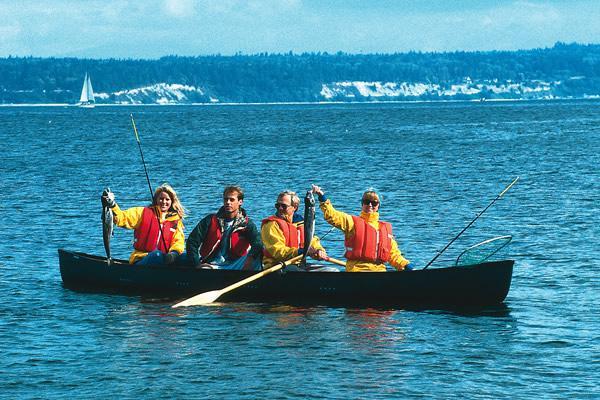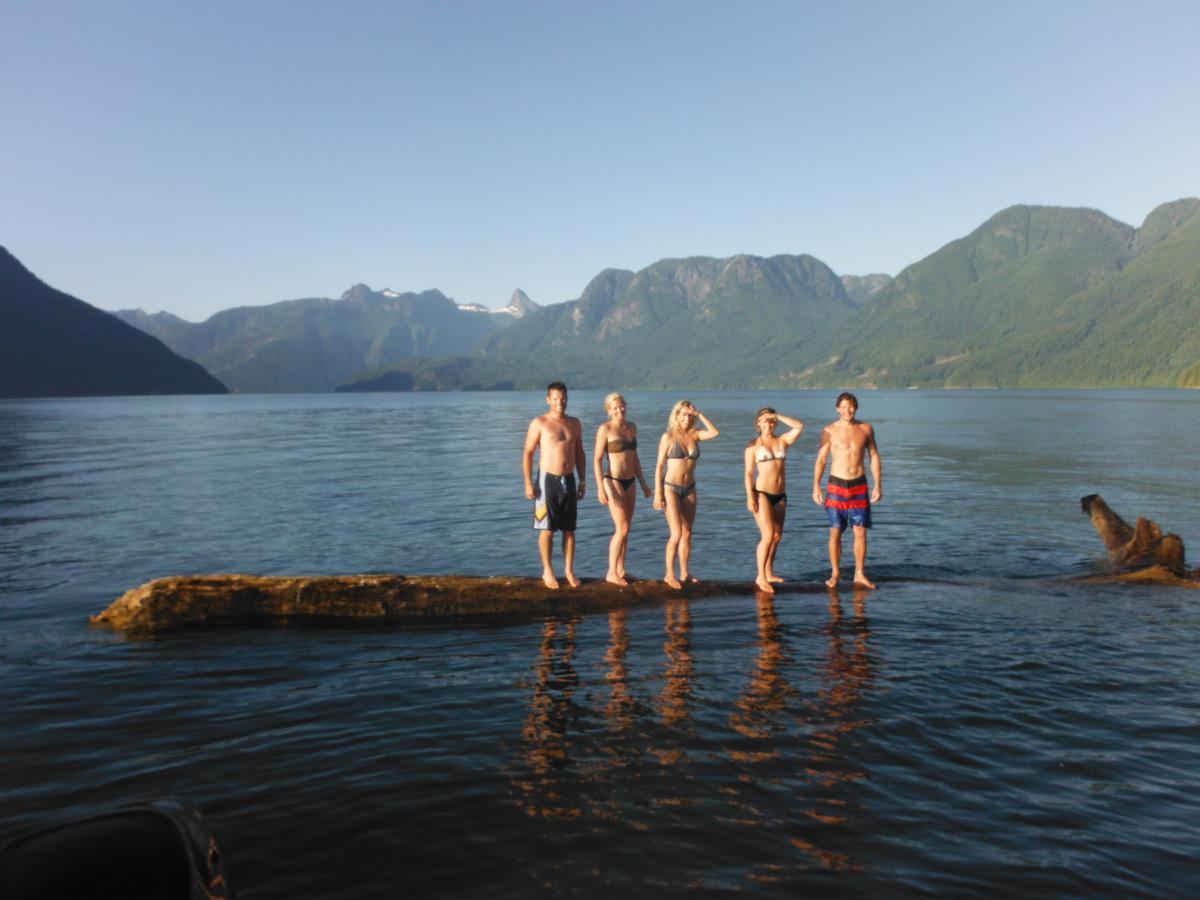The first image is the image on the left, the second image is the image on the right. Given the left and right images, does the statement "There are two vessels in the water in one of the images." hold true? Answer yes or no. No. The first image is the image on the left, the second image is the image on the right. Evaluate the accuracy of this statement regarding the images: "An image shows one boat with at least four aboard going to the right.". Is it true? Answer yes or no. Yes. 